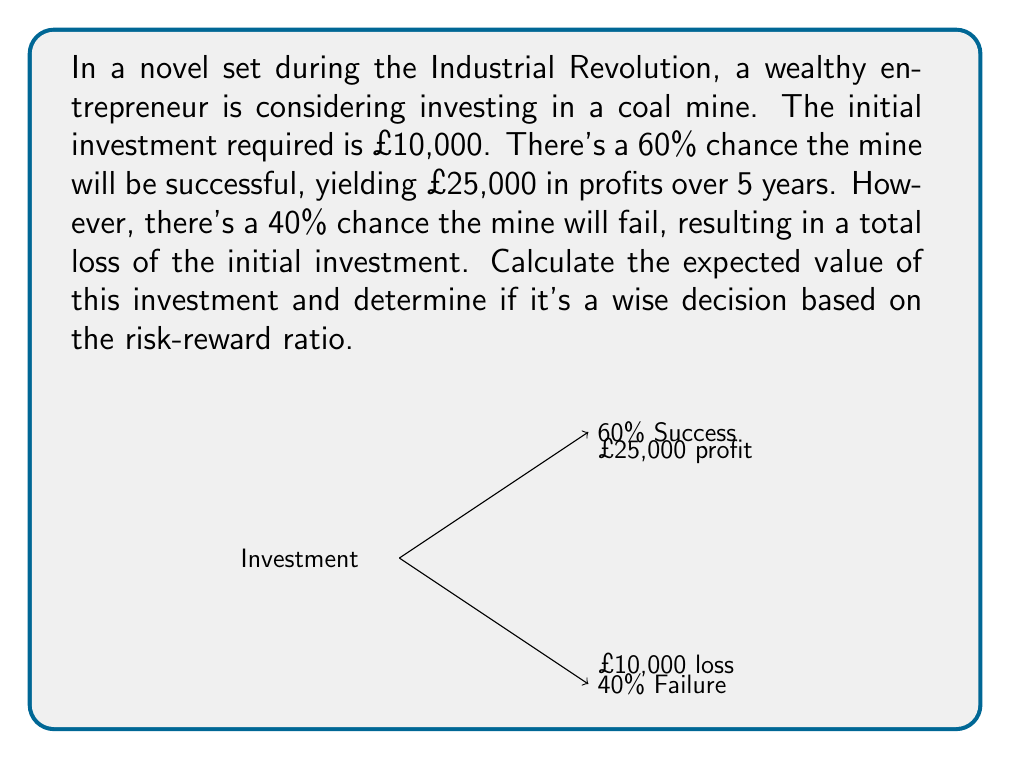Can you solve this math problem? Let's approach this problem step-by-step using probability theory and expected value calculations:

1) First, let's define our variables:
   $I$ = Initial investment = £10,000
   $P$ = Profit if successful = £25,000
   $p_s$ = Probability of success = 60% = 0.6
   $p_f$ = Probability of failure = 40% = 0.4

2) The expected value (EV) of an investment is calculated by multiplying each possible outcome by its probability and summing these products. In this case:

   $EV = (p_s \times (P - I)) + (p_f \times (-I))$

3) Let's substitute our values:

   $EV = (0.6 \times (25000 - 10000)) + (0.4 \times (-10000))$

4) Simplify:

   $EV = (0.6 \times 15000) + (-4000)$
   $EV = 9000 - 4000$
   $EV = 5000$

5) The expected value is positive at £5,000, which suggests that on average, this investment would be profitable.

6) To assess the risk-reward ratio, we can calculate the ratio of potential gain to potential loss:

   Risk-Reward Ratio = $\frac{\text{Potential Gain}}{\text{Potential Loss}} = \frac{25000}{10000} = 2.5$

   This means that the potential gain is 2.5 times the potential loss.

7) We can also calculate the break-even probability:

   $0.6 \times 25000 = 10000 \times (1 + x)$
   $15000 = 10000 + 10000x$
   $5000 = 10000x$
   $x = 0.5$ or 50%

   This means that as long as the probability of success is greater than 50%, the investment has a positive expected value.
Answer: Expected Value: £5,000. The investment is potentially wise with a positive expected value and a favorable risk-reward ratio of 2.5:1, given the 60% success probability exceeds the 50% break-even probability. 